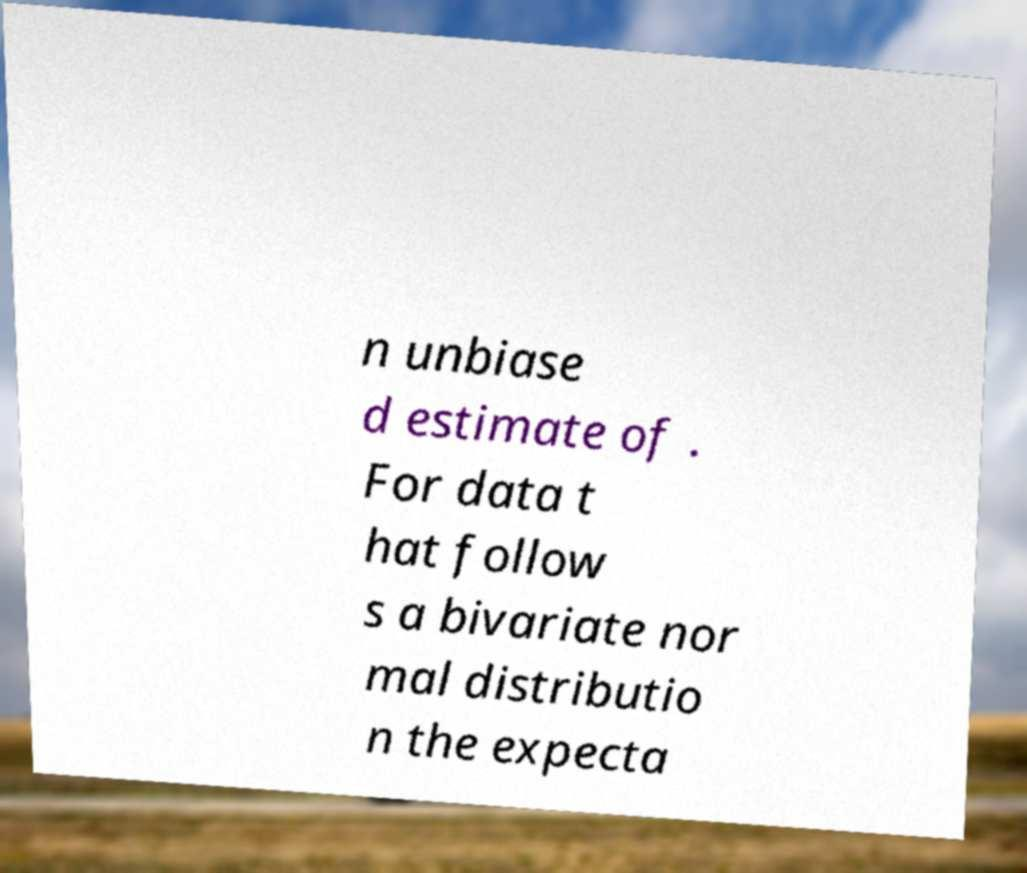Can you read and provide the text displayed in the image?This photo seems to have some interesting text. Can you extract and type it out for me? n unbiase d estimate of . For data t hat follow s a bivariate nor mal distributio n the expecta 